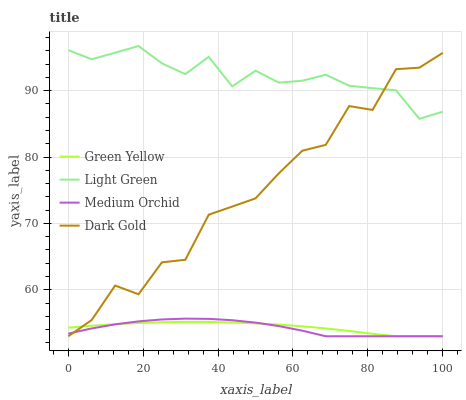Does Medium Orchid have the minimum area under the curve?
Answer yes or no. Yes. Does Light Green have the maximum area under the curve?
Answer yes or no. Yes. Does Green Yellow have the minimum area under the curve?
Answer yes or no. No. Does Green Yellow have the maximum area under the curve?
Answer yes or no. No. Is Green Yellow the smoothest?
Answer yes or no. Yes. Is Dark Gold the roughest?
Answer yes or no. Yes. Is Light Green the smoothest?
Answer yes or no. No. Is Light Green the roughest?
Answer yes or no. No. Does Light Green have the lowest value?
Answer yes or no. No. Does Green Yellow have the highest value?
Answer yes or no. No. Is Medium Orchid less than Light Green?
Answer yes or no. Yes. Is Light Green greater than Green Yellow?
Answer yes or no. Yes. Does Medium Orchid intersect Light Green?
Answer yes or no. No. 